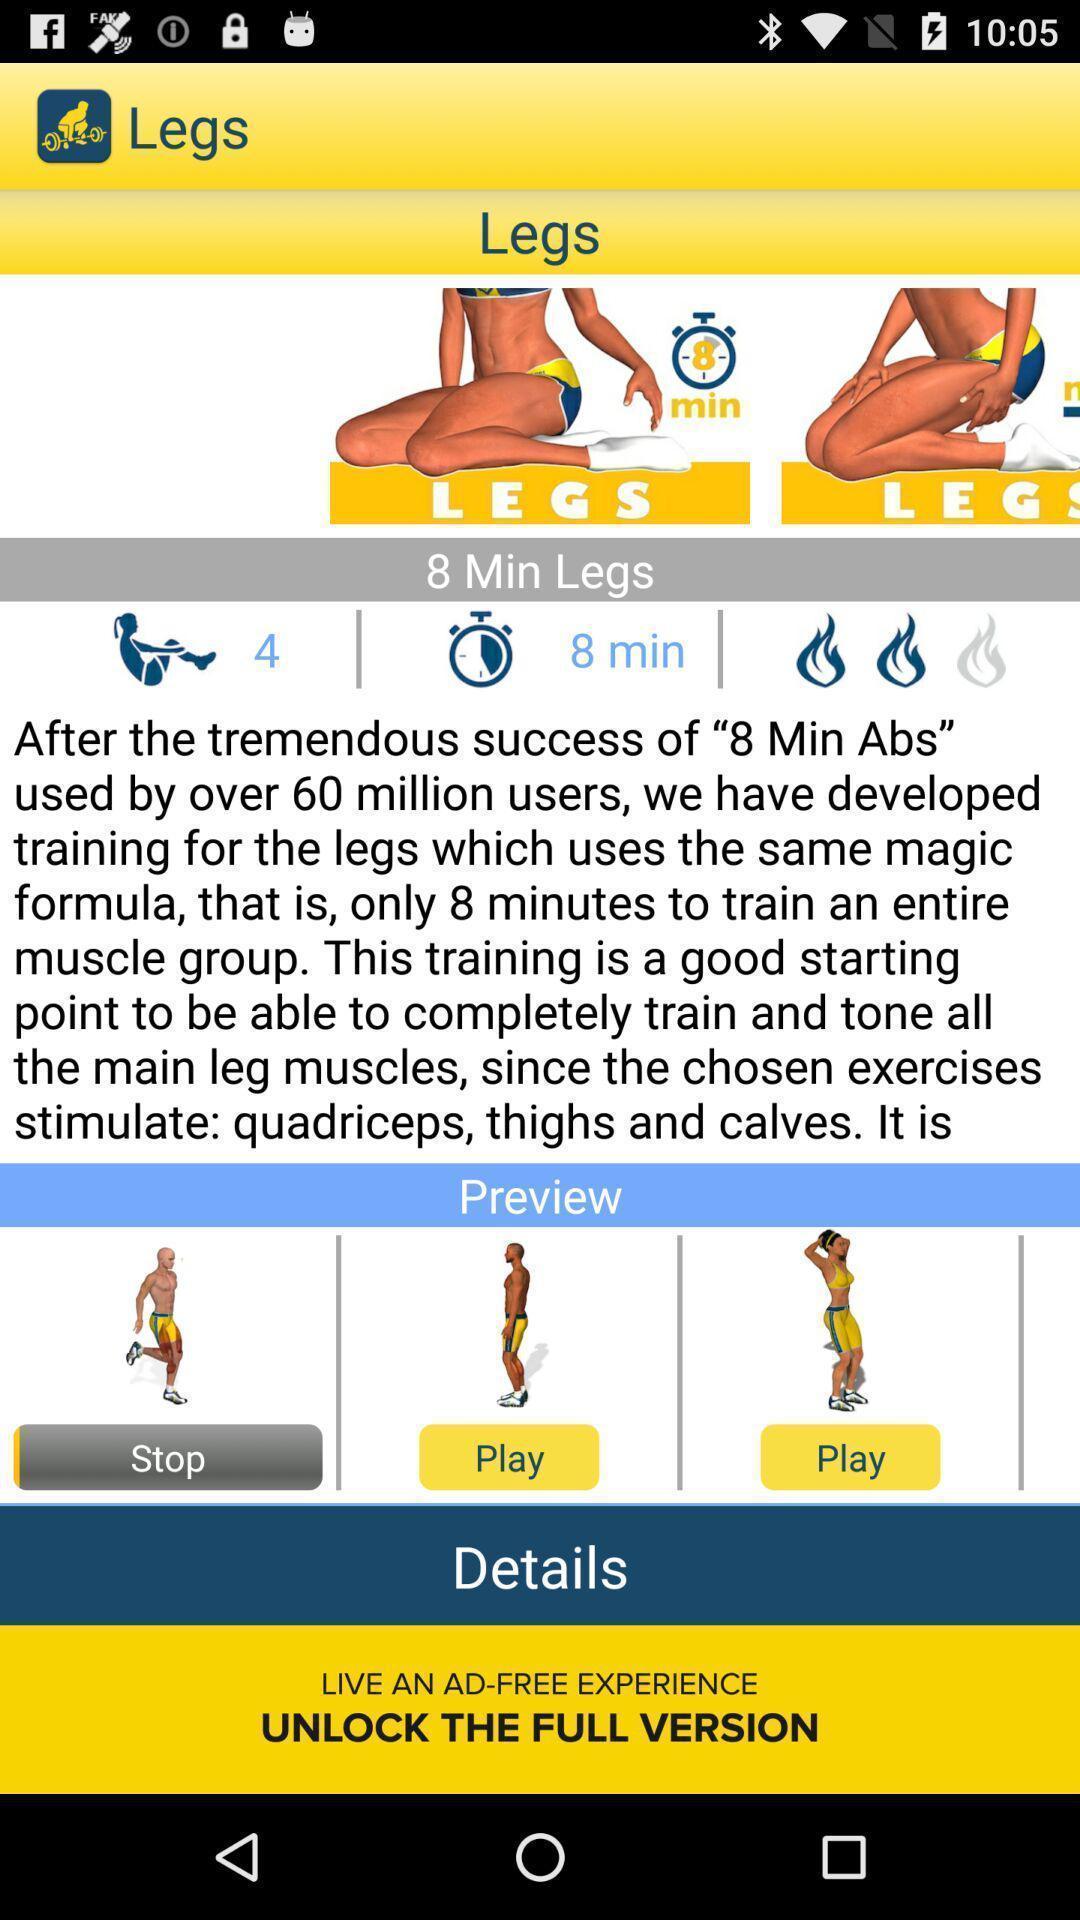Provide a detailed account of this screenshot. Set of legs information in a fitness app. 